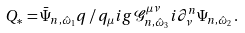Convert formula to latex. <formula><loc_0><loc_0><loc_500><loc_500>Q _ { * } & = \bar { \Psi } _ { n , \hat { \omega } _ { 1 } } q \, \slash \, q _ { \mu } i g \mathcal { G } ^ { \mu \nu } _ { n , \hat { \omega } _ { 3 } } i \partial ^ { n } _ { \nu } \Psi _ { n , \hat { \omega } _ { 2 } } \, .</formula> 